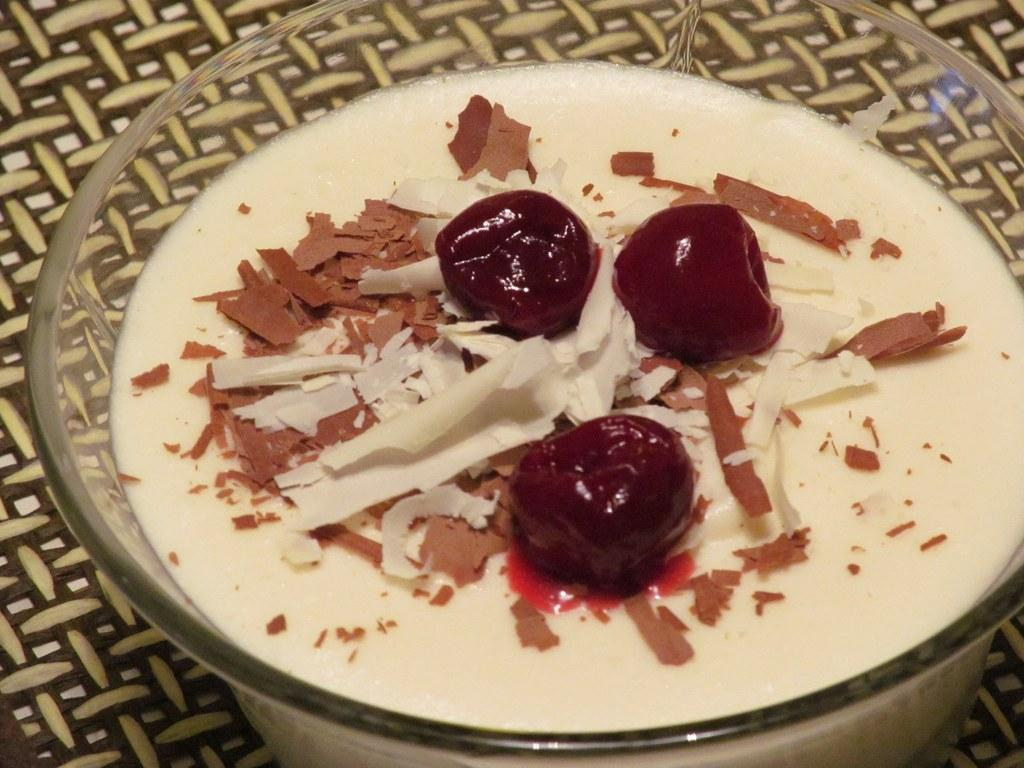What is the main subject of the image? The image is a zoomed-in picture of a food item. How is the food item contained in the image? The food item is in a bowl. Is there any additional context provided for the bowl in the image? Yes, the bowl is placed on a table mat. What type of bait is used to catch fish in the image? There is no bait or fishing activity present in the image; it is a picture of a food item in a bowl. Can you see any sparks or electrical activity in the image? No, there are no sparks or electrical activity visible in the image. 